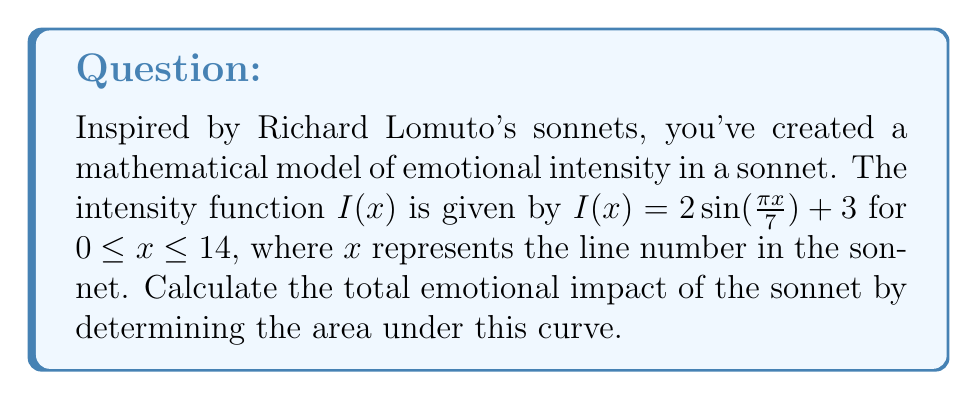What is the answer to this math problem? To find the area under the curve, we need to integrate the function $I(x)$ from 0 to 14.

1) Set up the definite integral:
   $$\int_0^{14} (2\sin(\frac{\pi x}{7}) + 3) dx$$

2) Split the integral:
   $$\int_0^{14} 2\sin(\frac{\pi x}{7}) dx + \int_0^{14} 3 dx$$

3) For the first part, let $u = \frac{\pi x}{7}$, so $du = \frac{\pi}{7} dx$ and $dx = \frac{7}{\pi} du$:
   $$\frac{14}{\pi} \int_0^{2\pi} \sin(u) du + 3x\Big|_0^{14}$$

4) Evaluate:
   $$\frac{14}{\pi} [-\cos(u)]_0^{2\pi} + 3(14)$$
   $$= \frac{14}{\pi} [-\cos(2\pi) + \cos(0)] + 42$$
   $$= \frac{14}{\pi} [-(1) + 1] + 42$$
   $$= 0 + 42 = 42$$

5) Therefore, the total area under the curve is 42 units squared.
Answer: 42 square units 